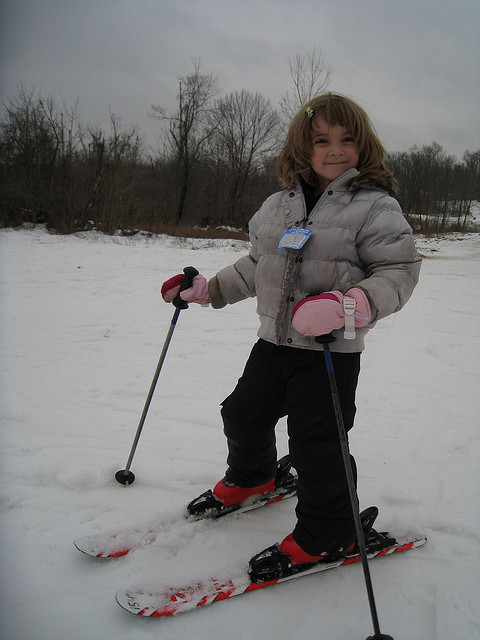Is this picture taken in North Dakota? Without any distinct landmarks or signs that are specific to North Dakota, it's impossible to accurately determine the location where this picture was taken. 